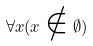Convert formula to latex. <formula><loc_0><loc_0><loc_500><loc_500>\forall x ( x \notin \emptyset )</formula> 